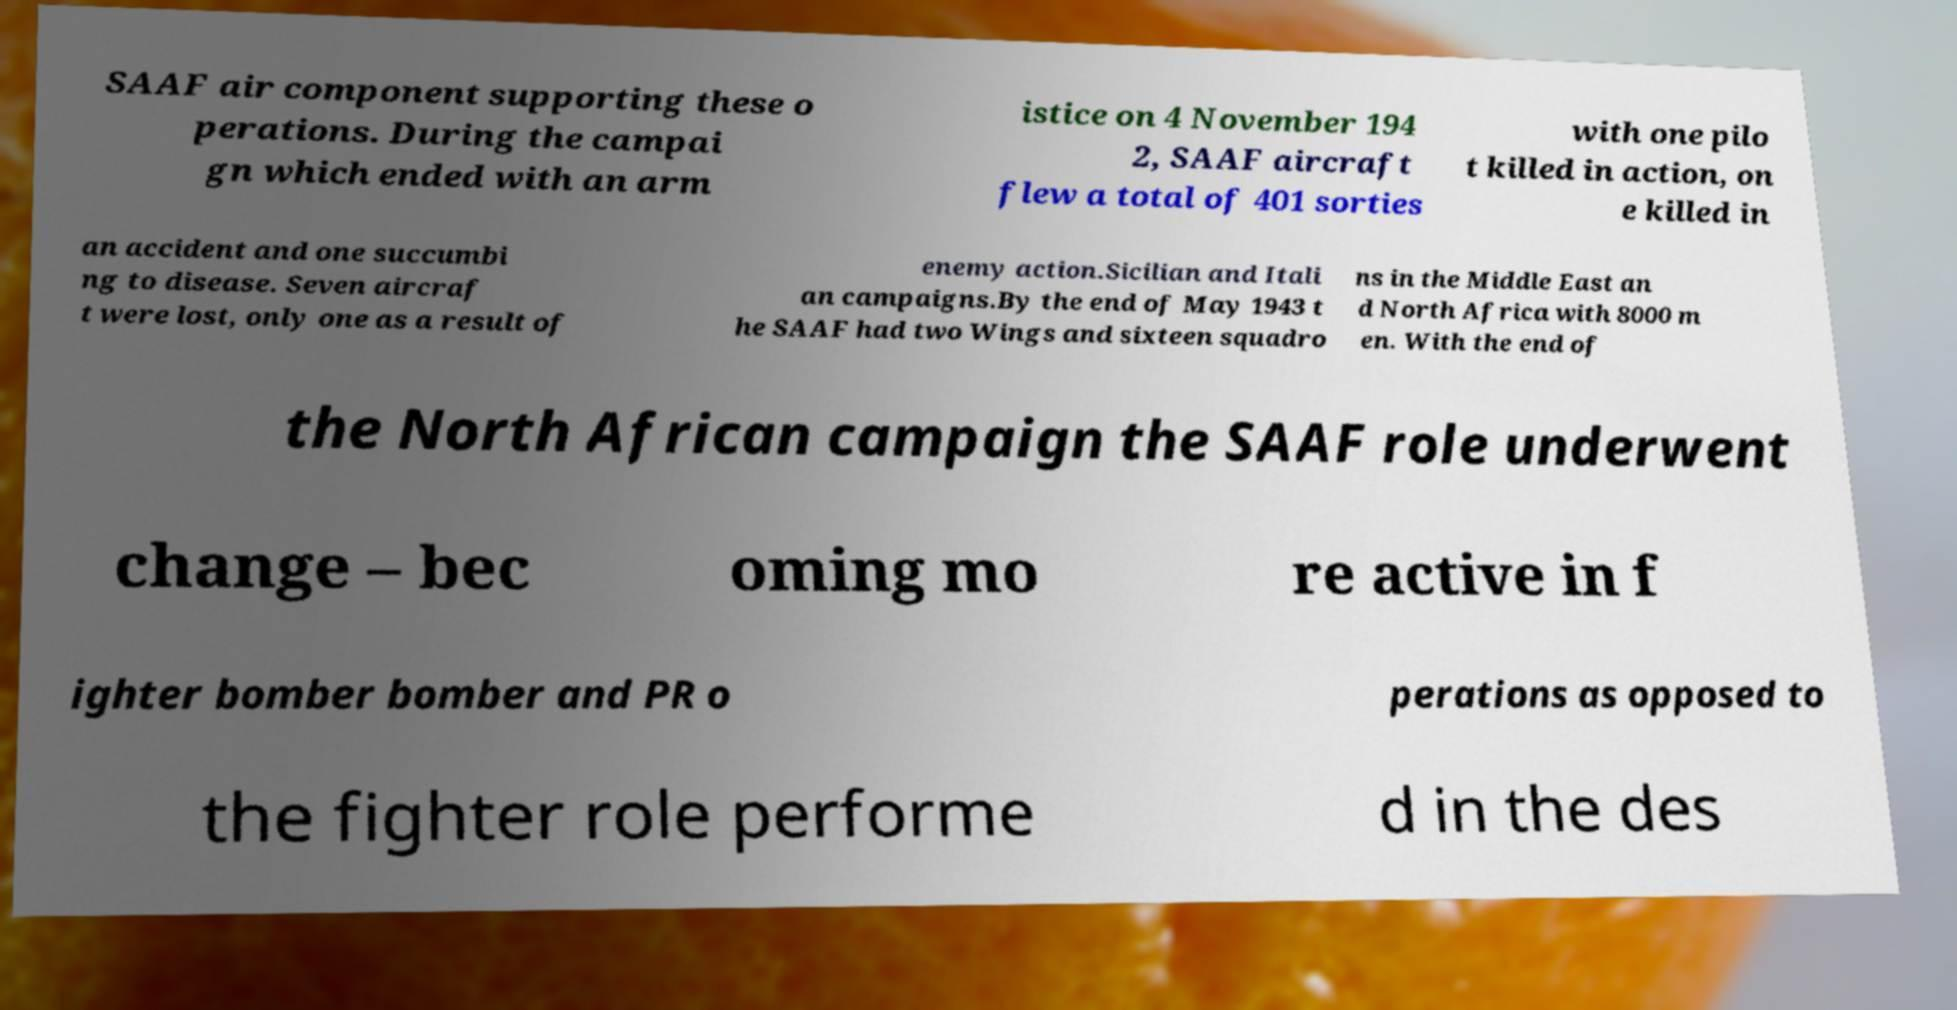For documentation purposes, I need the text within this image transcribed. Could you provide that? SAAF air component supporting these o perations. During the campai gn which ended with an arm istice on 4 November 194 2, SAAF aircraft flew a total of 401 sorties with one pilo t killed in action, on e killed in an accident and one succumbi ng to disease. Seven aircraf t were lost, only one as a result of enemy action.Sicilian and Itali an campaigns.By the end of May 1943 t he SAAF had two Wings and sixteen squadro ns in the Middle East an d North Africa with 8000 m en. With the end of the North African campaign the SAAF role underwent change – bec oming mo re active in f ighter bomber bomber and PR o perations as opposed to the fighter role performe d in the des 